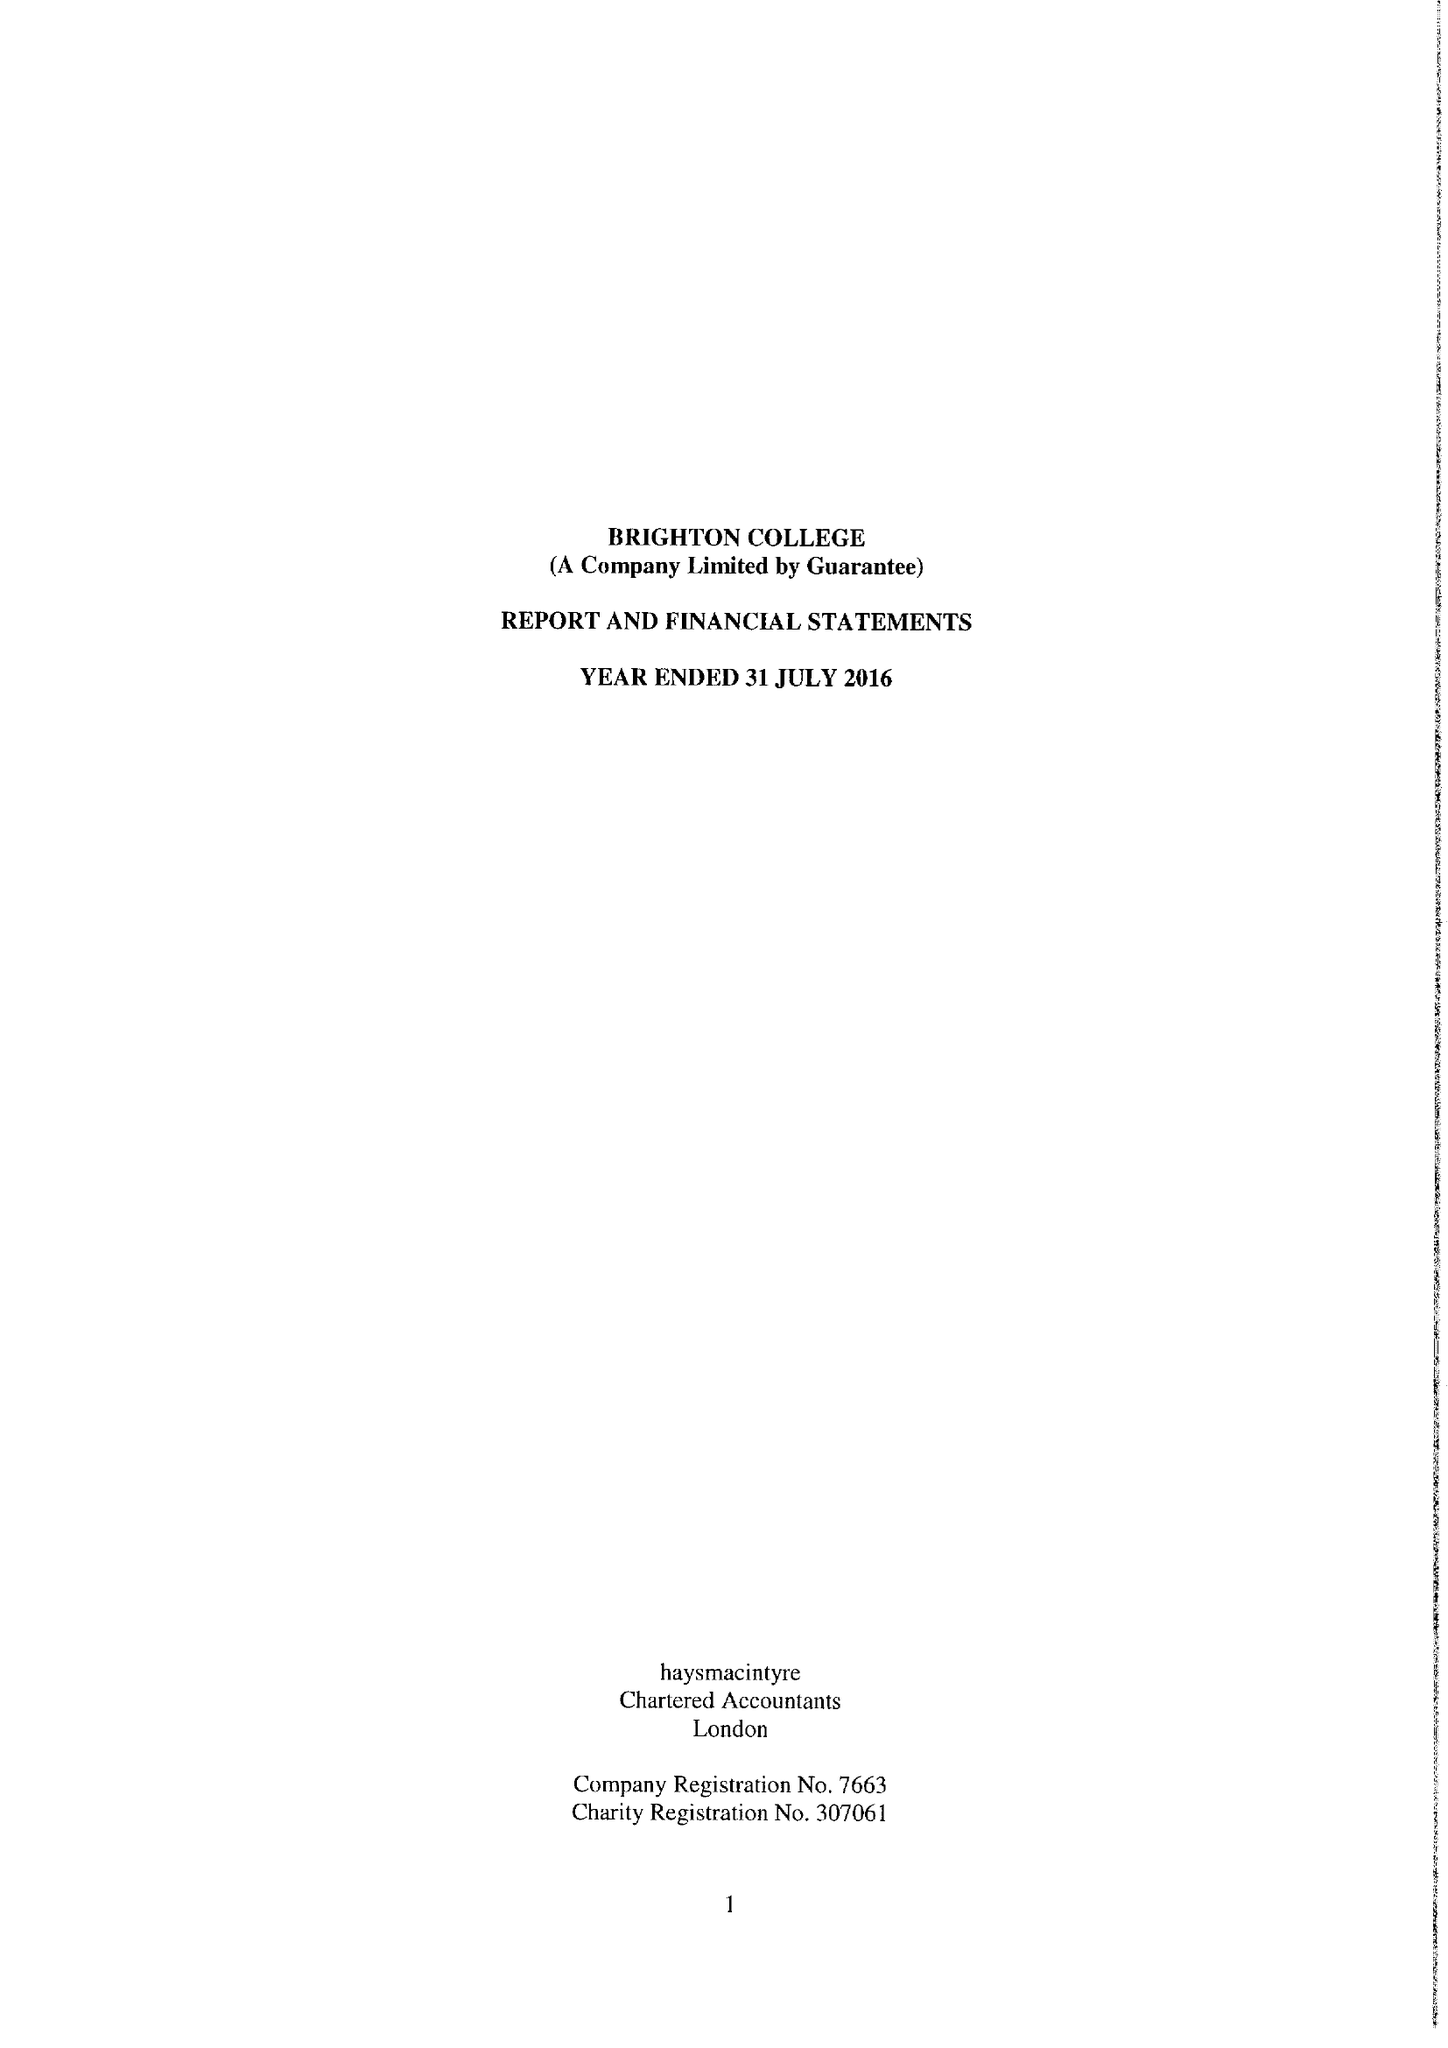What is the value for the charity_number?
Answer the question using a single word or phrase. 307061 